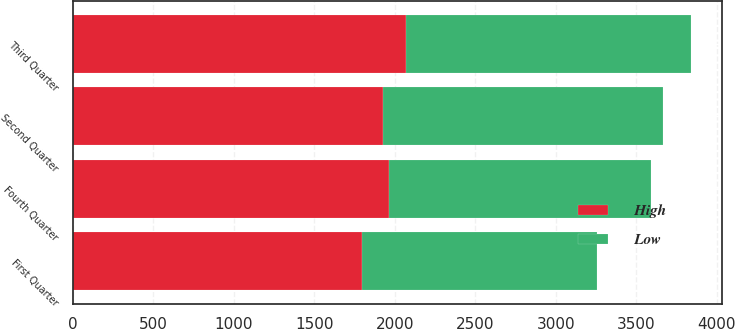Convert chart to OTSL. <chart><loc_0><loc_0><loc_500><loc_500><stacked_bar_chart><ecel><fcel>First Quarter<fcel>Second Quarter<fcel>Third Quarter<fcel>Fourth Quarter<nl><fcel>High<fcel>1798.75<fcel>1927.13<fcel>2067.99<fcel>1961.45<nl><fcel>Low<fcel>1459.49<fcel>1738.34<fcel>1774.4<fcel>1630.56<nl></chart> 